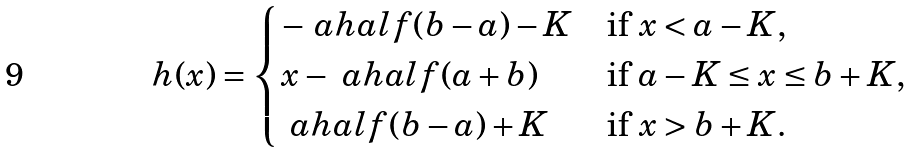Convert formula to latex. <formula><loc_0><loc_0><loc_500><loc_500>h ( x ) = \begin{cases} - \ a h a l f ( b - a ) - K & \text {if $x<a-K$,} \\ x - \ a h a l f ( a + b ) & \text {if $a-K\leq x\leq b+K$,} \\ \ a h a l f ( b - a ) + K & \text {if $x>b+K$.} \end{cases}</formula> 